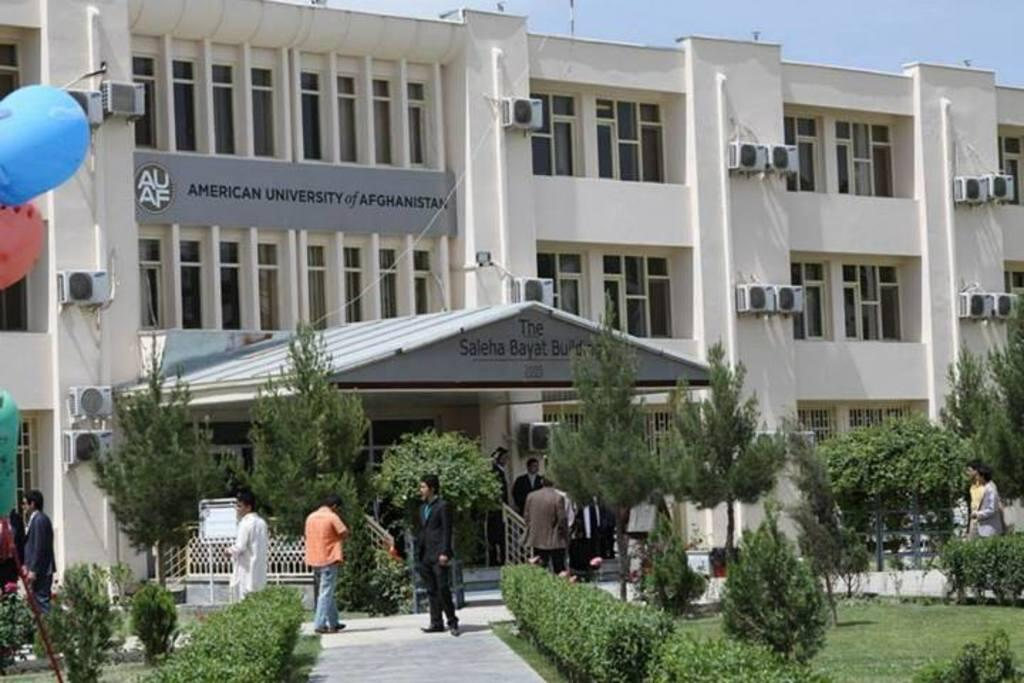What is happening on the ground in the image? There are people on the ground in the image. What type of vegetation can be seen in the image? There are plants and trees in the image. What architectural feature is present in the image? There is a fence in the image. What can be seen in the background of the image? There is a building, balloons, air conditioners, and the sky visible in the background of the image. What channel is the person watching on the ground in the image? There is no television or channel visible in the image; it only shows people on the ground. What type of loss is being experienced by the trees in the image? There is no indication of any loss experienced by the trees in the image; they appear to be healthy and growing. 